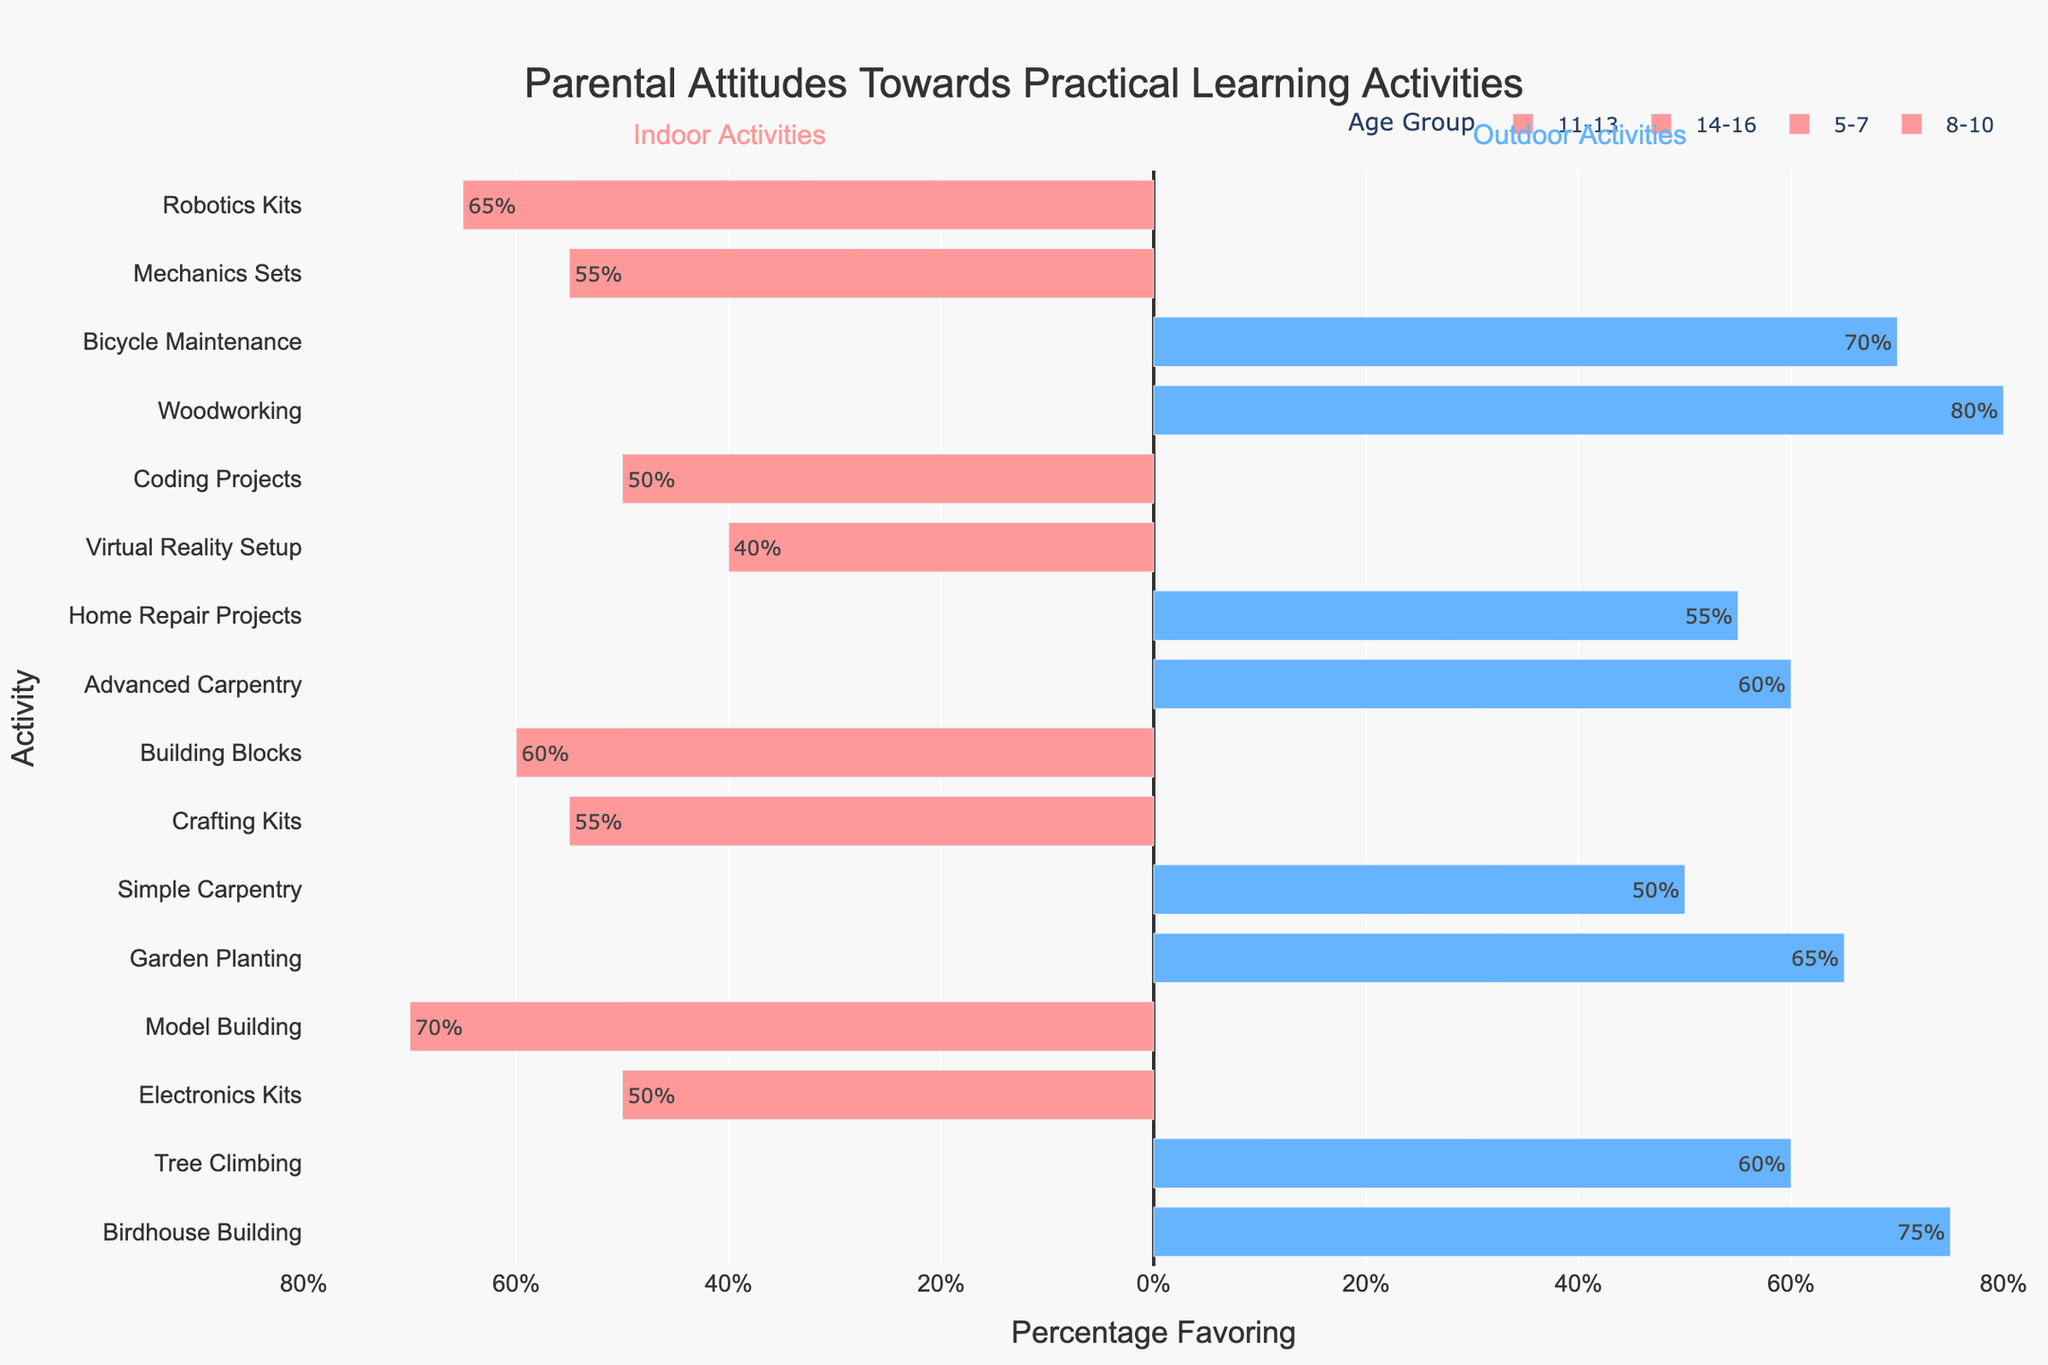Which age group has the highest preference for any indoor activity? Look at each age group and check the highest preference for indoor activities. The 8-10 age group has a 70% preference for Model Building, which is the highest among indoor activities.
Answer: 8-10 Which activity has the lowest preference among 14-16 year olds? Examine both indoor and outdoor activities for the 14-16 age group. Virtual Reality Setup has the lowest preference at 40%.
Answer: Virtual Reality Setup How does the preference for outdoor activities compare between ages 5-7 and 8-10? Look at the values for outdoor activities in both age groups. For 5-7, the preferences are 65% (Garden Planting) and 50% (Simple Carpentry). For 8-10, they are 75% (Birdhouse Building) and 60% (Tree Climbing). The preferences in the 8-10 age group are generally higher.
Answer: Higher for 8-10 What is the average preference for indoor activities within 11-13 year olds? Sum the indoor preferences for 11-13-year-olds: 65% (Robotics Kits) and 55% (Mechanics Sets), then divide by 2. (65 + 55)/2 = 60%
Answer: 60% Which has a higher preference among 11-13 year olds: Woodworking or Bicycle Maintenance? Compare the values for Woodworking (80%) and Bicycle Maintenance (70%), where Woodworking has a higher preference.
Answer: Woodworking Is there any age group where the preference for indoor activities is higher than for outdoor activities? Compare the summed preferences for indoor and outdoor activities within each age group. In the age group 8-10, the summed indoor preferences (70% + 50% = 120%) are higher than the outdoor preferences (75% + 60% = 135%). No age group has higher indoor preferences.
Answer: No What is the total percentage favoring outdoor activities in the 5-7 age group? Add the favoring percentages for all outdoor activities in the 5-7 age group: 65% (Garden Planting) + 50% (Simple Carpentry) = 115%
Answer: 115% Which indoor activity among 5-7 year olds has the highest preference? Compare the preference values for indoor activities in the 5-7 age group: 60% (Building Blocks) and 55% (Crafting Kits). Building Blocks has the highest preference.
Answer: Building Blocks Do more parents favor outdoor activities over indoor ones for the 14-16 age group? Compare the summed preferences for outdoor (60% + 55% = 115%) and indoor activities (50% + 40% = 90%) in the 14-16 age group. More parents favor outdoor activities.
Answer: Yes 